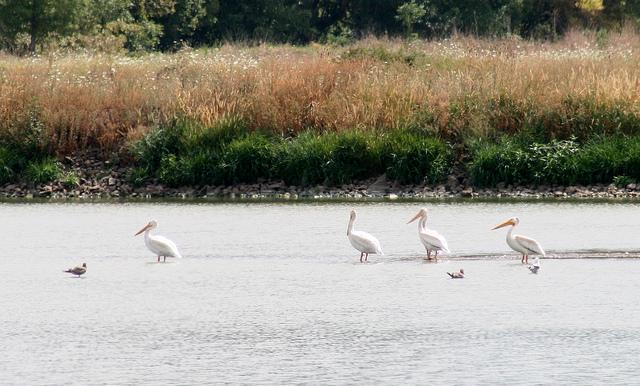How many people?
Give a very brief answer. 0. How many bird are visible?
Give a very brief answer. 7. How many birds are in this water?
Give a very brief answer. 7. How many people have on backpacks?
Give a very brief answer. 0. 